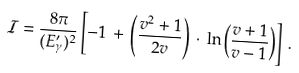<formula> <loc_0><loc_0><loc_500><loc_500>\mathcal { I } = \frac { 8 \pi } { ( E ^ { \prime } _ { \gamma } ) ^ { 2 } } \left [ - 1 \, + \, \left ( \frac { v ^ { 2 } + 1 } { 2 v } \right ) \, \cdot \, \ln \left ( \frac { v + 1 } { v - 1 } \right ) \right ] \, .</formula> 